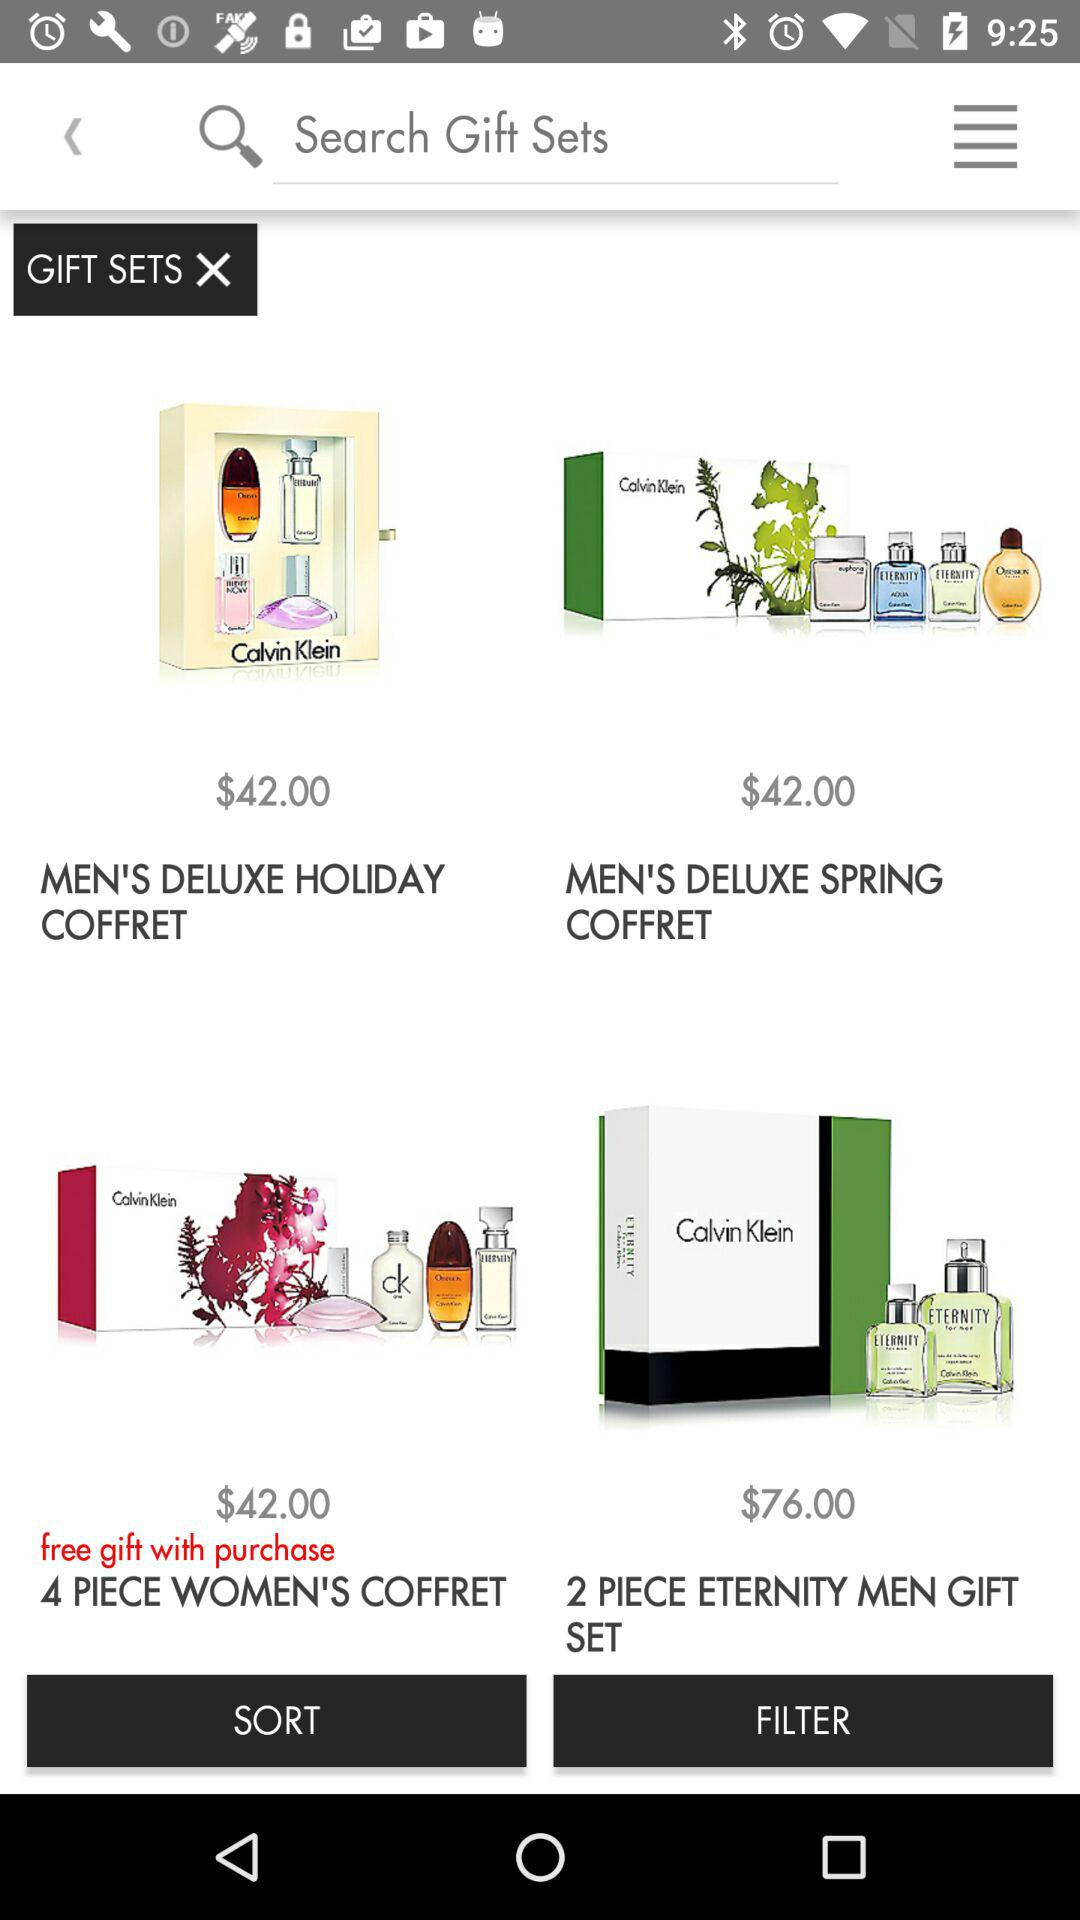What is the price of the men's deluxe holiday coffret? The price is $42.00. 